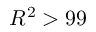Convert formula to latex. <formula><loc_0><loc_0><loc_500><loc_500>R ^ { 2 } > 9 9 \</formula> 